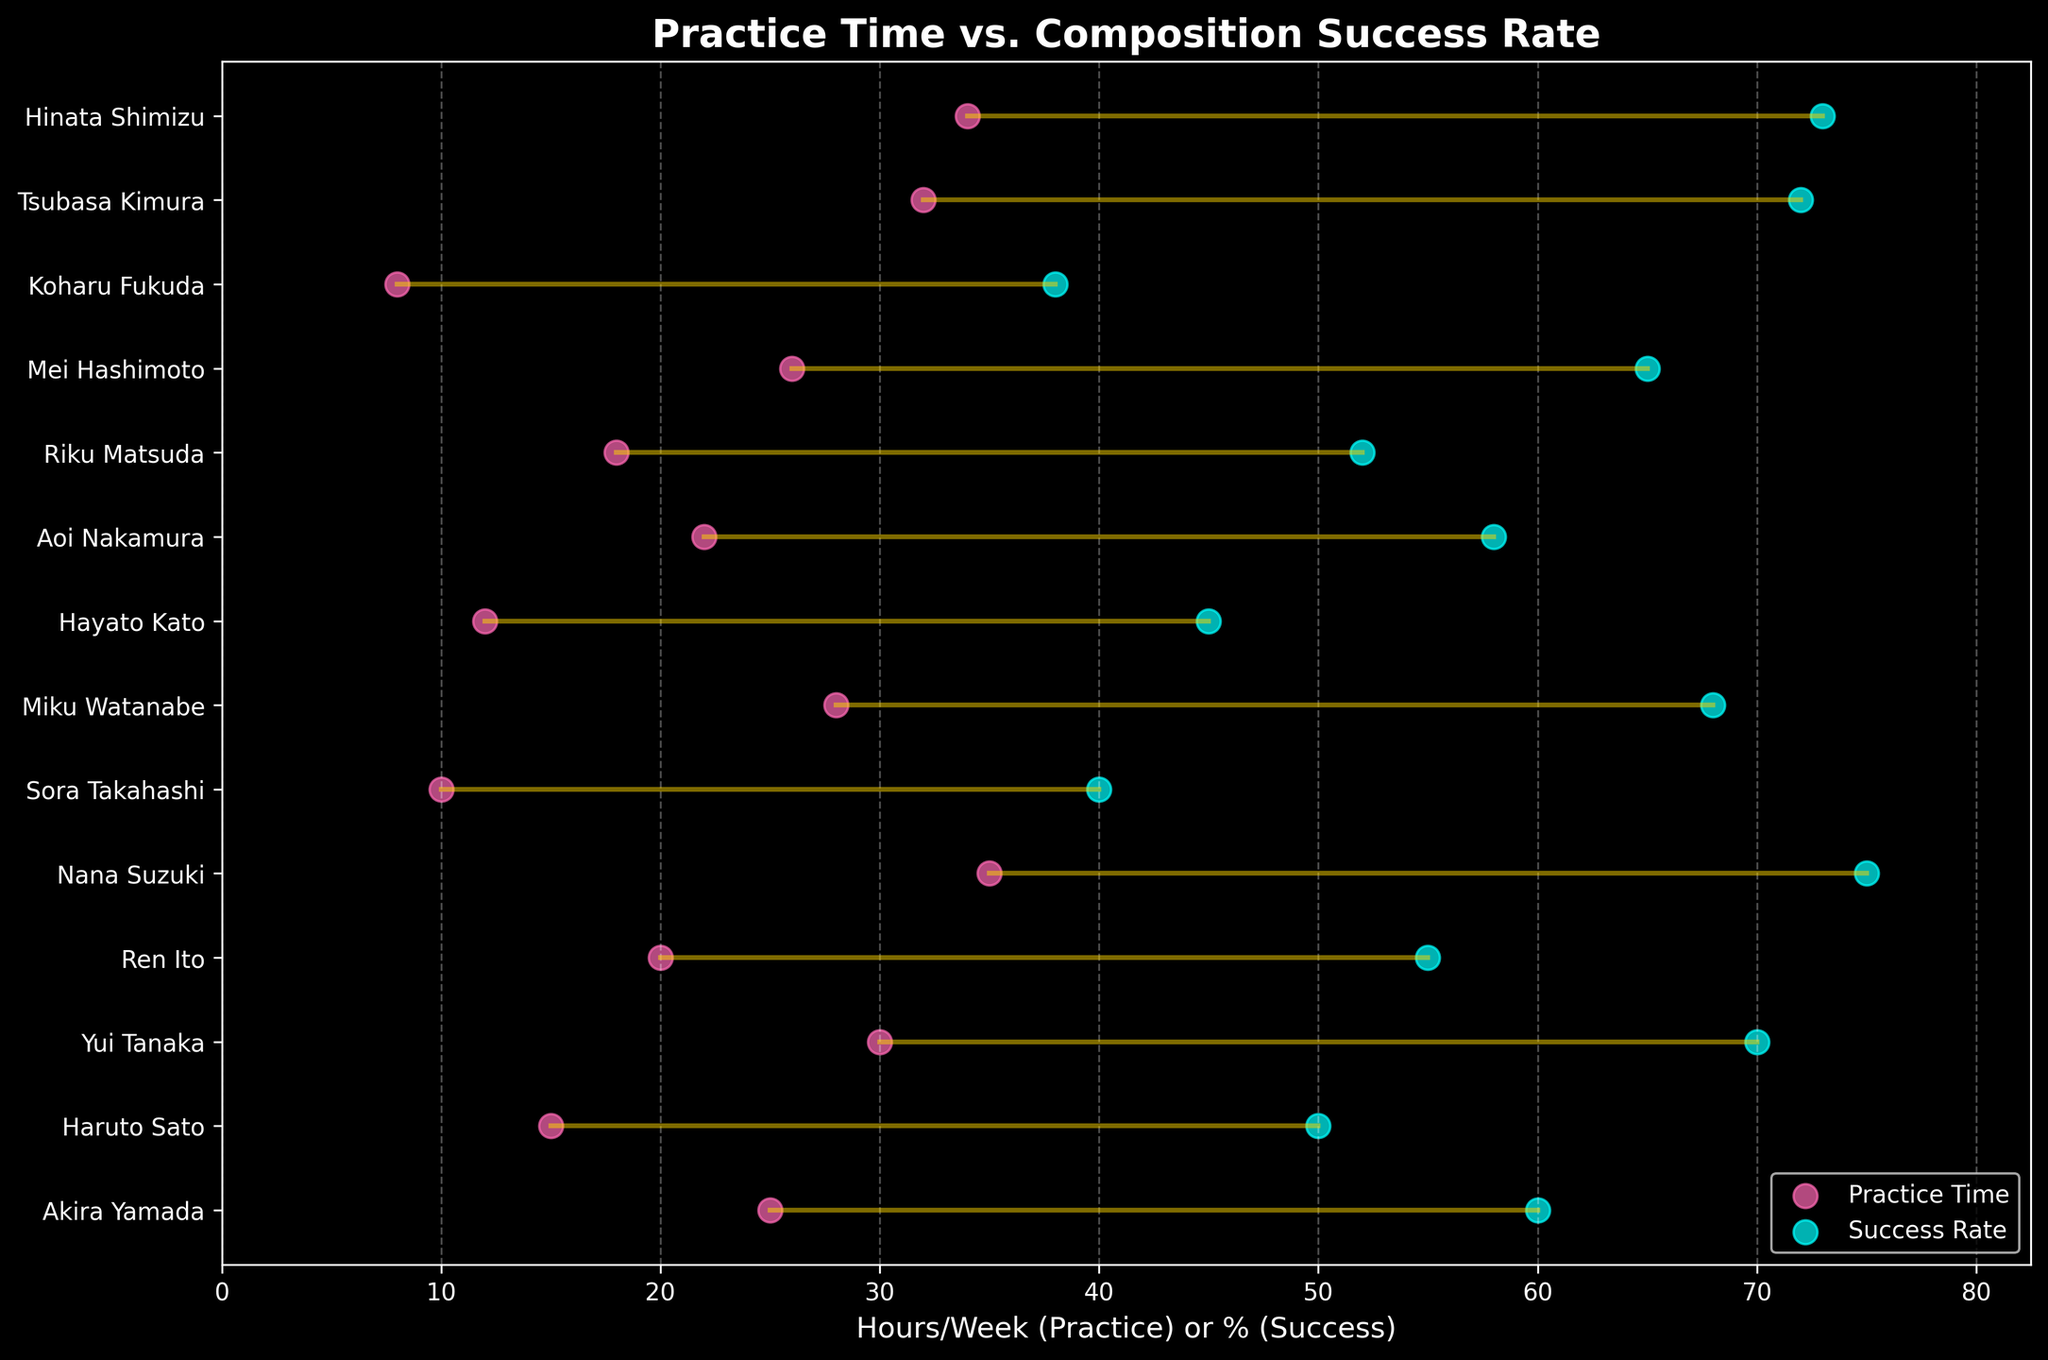How does Akira Yamada's practice time compare to their composition success rate? Akira Yamada's practice time is represented by one dot and their composition success rate by another dot on the y-axis line labeled with their name. The practice time dot is at 25 hours/week and the success rate dot is at 60%. Akira practices 25 hours/week and has a 60% success rate.
Answer: Practice: 25 hours/week, Success Rate: 60% Which aspiring composer has the highest composition success rate? Examine the rightmost dot (success rate) for each composer. The highest rightmost dot is Nana Suzuki's at 75%.
Answer: Nana Suzuki What's the difference between Nana Suzuki's practice time and composition success rate? Find the distance between Nana Suzuki's two dots on the x-axis. Her practice time is 35 hours/week and her success rate is 75%. The difference is 75 - 35 = 40.
Answer: 40% What is the average practice time among all composers? Sum the practice times of all composers and divide by the number of composers. (25 + 15 + 30 + 20 + 35 + 10 + 28 + 12 + 22 + 18 + 26 + 8 + 32 + 34) / 14 = 285 / 14 ≈ 20.36 hours/week
Answer: 20.36 hours/week How many composers have a success rate greater than 70%? Identify the number of success rate dots to the right of 70% on the x-axis. Yui Tanaka (70%), Nana Suzuki (75%), Tsubasa Kimura (72%), and Hinata Shimizu (73%) each have success rates above 70%.
Answer: 4 Compare the practice times and success rates of Yui Tanaka and Mei Hashimoto. Which one has a higher success rate? Yui Tanaka practices 30 hours/week with a 70% success rate, while Mei Hashimoto practices 26 hours/week with a 65% success rate. Comparing the rightmost dots, Yui Tanaka has a higher success rate.
Answer: Yui Tanaka What is the range of practice times among the composers? The lowest practice time is Koharu Fukuda's 8 hours/week, and the highest is Nana Suzuki's 35 hours/week. The range is 35 - 8 = 27 hours/week.
Answer: 27 hours/week Who has the smallest difference between practice time and success rate? Examine the distance between the two dots for each composer. The smallest difference is for Sora Takahashi, who practices 10 hours/week with a 40% success rate, making a difference of 40 - 10 = 30.
Answer: Sora Takahashi What is the general trend between practice time and composition success rate? From visual inspection, it appears that as practice time increases, the composition success rate tends to increase as well, showing a positive correlation.
Answer: Positive correlation 